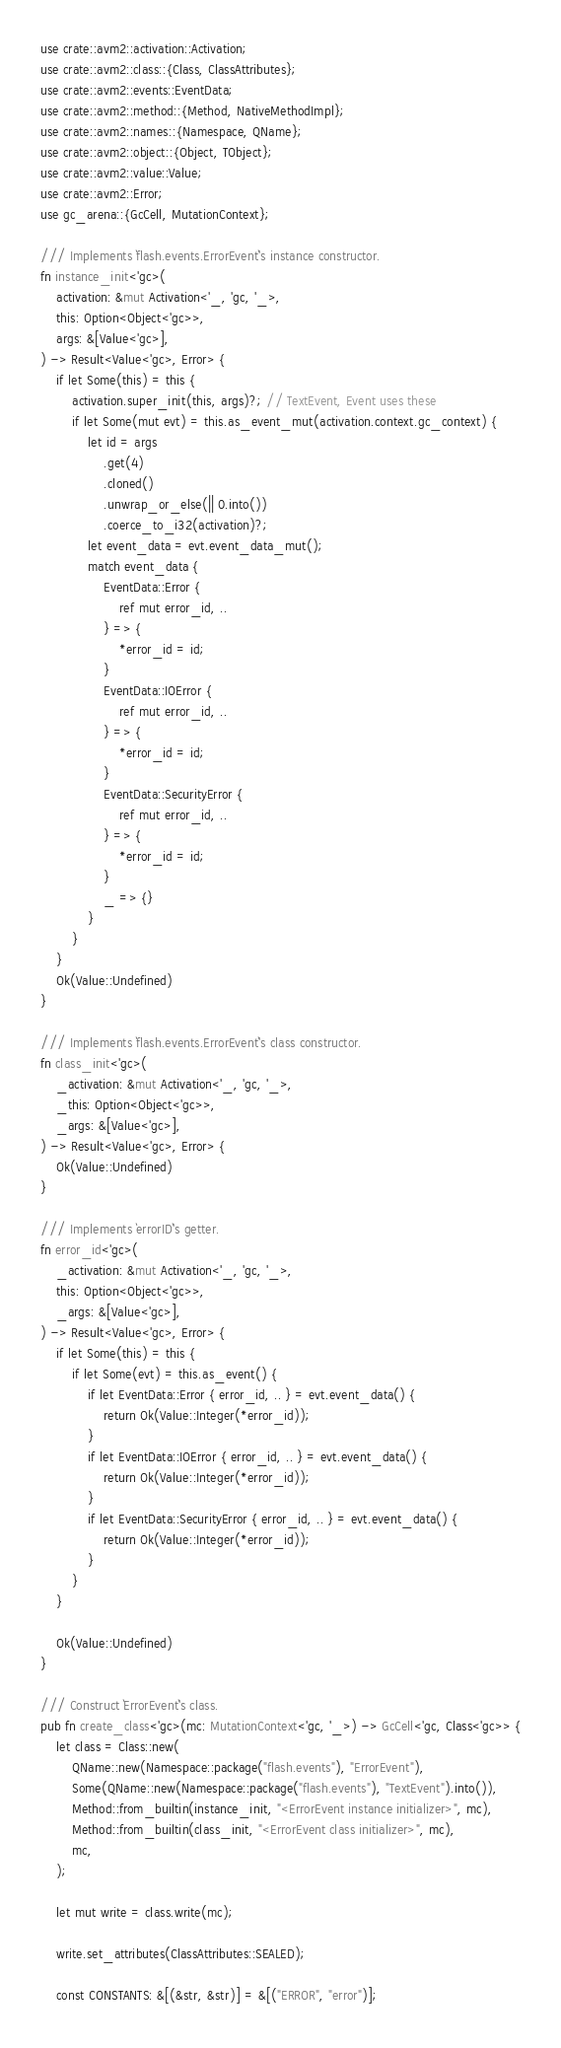<code> <loc_0><loc_0><loc_500><loc_500><_Rust_>use crate::avm2::activation::Activation;
use crate::avm2::class::{Class, ClassAttributes};
use crate::avm2::events::EventData;
use crate::avm2::method::{Method, NativeMethodImpl};
use crate::avm2::names::{Namespace, QName};
use crate::avm2::object::{Object, TObject};
use crate::avm2::value::Value;
use crate::avm2::Error;
use gc_arena::{GcCell, MutationContext};

/// Implements `flash.events.ErrorEvent`'s instance constructor.
fn instance_init<'gc>(
    activation: &mut Activation<'_, 'gc, '_>,
    this: Option<Object<'gc>>,
    args: &[Value<'gc>],
) -> Result<Value<'gc>, Error> {
    if let Some(this) = this {
        activation.super_init(this, args)?; // TextEvent, Event uses these
        if let Some(mut evt) = this.as_event_mut(activation.context.gc_context) {
            let id = args
                .get(4)
                .cloned()
                .unwrap_or_else(|| 0.into())
                .coerce_to_i32(activation)?;
            let event_data = evt.event_data_mut();
            match event_data {
                EventData::Error {
                    ref mut error_id, ..
                } => {
                    *error_id = id;
                }
                EventData::IOError {
                    ref mut error_id, ..
                } => {
                    *error_id = id;
                }
                EventData::SecurityError {
                    ref mut error_id, ..
                } => {
                    *error_id = id;
                }
                _ => {}
            }
        }
    }
    Ok(Value::Undefined)
}

/// Implements `flash.events.ErrorEvent`'s class constructor.
fn class_init<'gc>(
    _activation: &mut Activation<'_, 'gc, '_>,
    _this: Option<Object<'gc>>,
    _args: &[Value<'gc>],
) -> Result<Value<'gc>, Error> {
    Ok(Value::Undefined)
}

/// Implements `errorID`'s getter.
fn error_id<'gc>(
    _activation: &mut Activation<'_, 'gc, '_>,
    this: Option<Object<'gc>>,
    _args: &[Value<'gc>],
) -> Result<Value<'gc>, Error> {
    if let Some(this) = this {
        if let Some(evt) = this.as_event() {
            if let EventData::Error { error_id, .. } = evt.event_data() {
                return Ok(Value::Integer(*error_id));
            }
            if let EventData::IOError { error_id, .. } = evt.event_data() {
                return Ok(Value::Integer(*error_id));
            }
            if let EventData::SecurityError { error_id, .. } = evt.event_data() {
                return Ok(Value::Integer(*error_id));
            }
        }
    }

    Ok(Value::Undefined)
}

/// Construct `ErrorEvent`'s class.
pub fn create_class<'gc>(mc: MutationContext<'gc, '_>) -> GcCell<'gc, Class<'gc>> {
    let class = Class::new(
        QName::new(Namespace::package("flash.events"), "ErrorEvent"),
        Some(QName::new(Namespace::package("flash.events"), "TextEvent").into()),
        Method::from_builtin(instance_init, "<ErrorEvent instance initializer>", mc),
        Method::from_builtin(class_init, "<ErrorEvent class initializer>", mc),
        mc,
    );

    let mut write = class.write(mc);

    write.set_attributes(ClassAttributes::SEALED);

    const CONSTANTS: &[(&str, &str)] = &[("ERROR", "error")];
</code> 